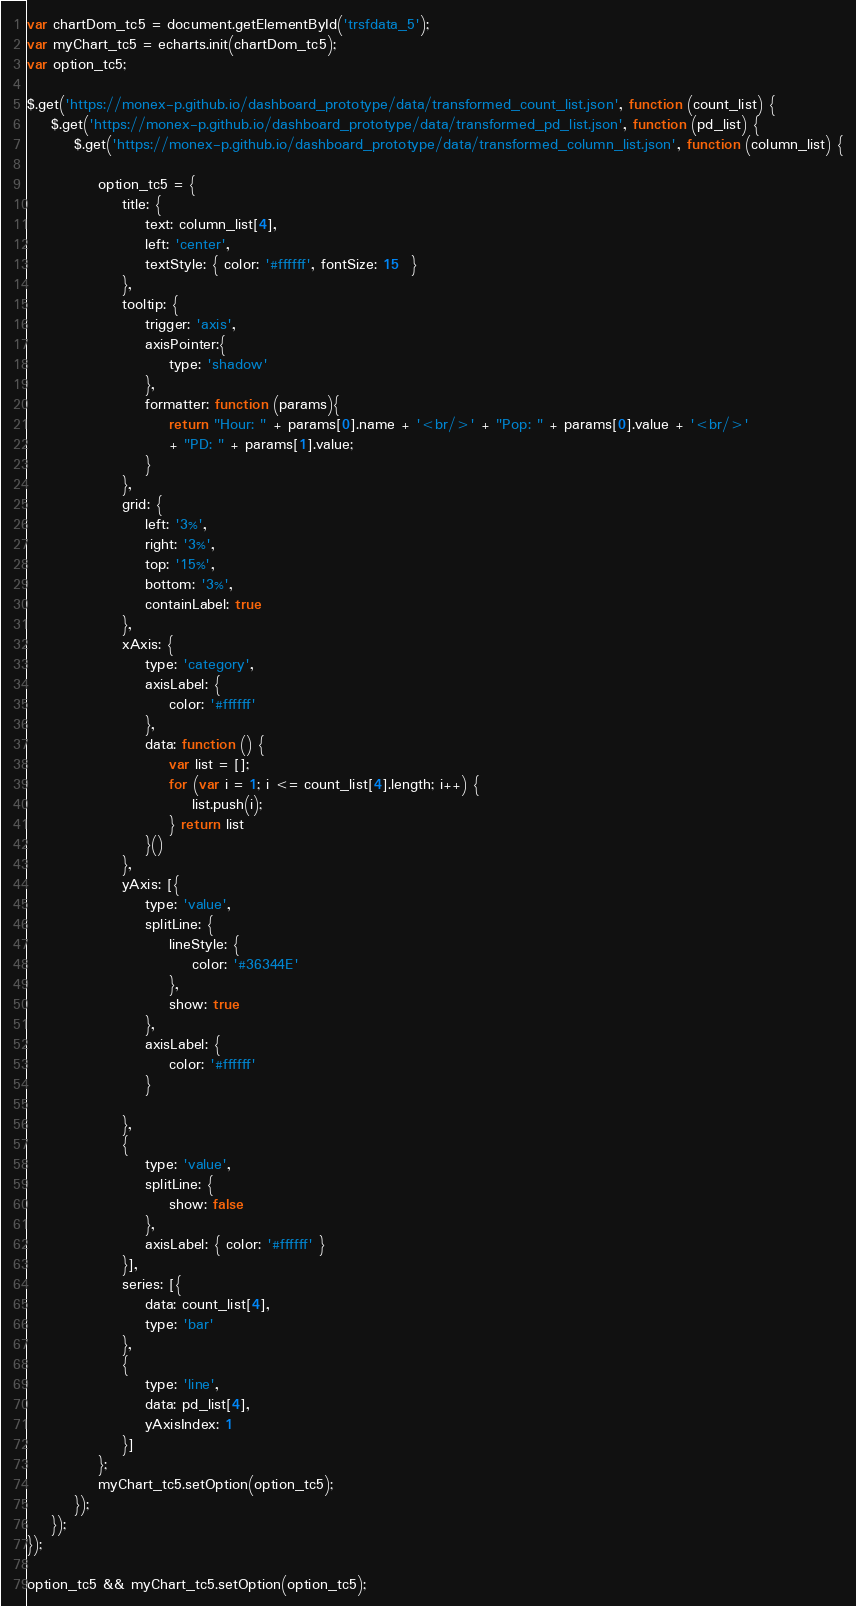<code> <loc_0><loc_0><loc_500><loc_500><_JavaScript_>var chartDom_tc5 = document.getElementById('trsfdata_5');
var myChart_tc5 = echarts.init(chartDom_tc5);
var option_tc5;

$.get('https://monex-p.github.io/dashboard_prototype/data/transformed_count_list.json', function (count_list) {
    $.get('https://monex-p.github.io/dashboard_prototype/data/transformed_pd_list.json', function (pd_list) {
        $.get('https://monex-p.github.io/dashboard_prototype/data/transformed_column_list.json', function (column_list) {

            option_tc5 = {
                title: {
                    text: column_list[4],
                    left: 'center',
                    textStyle: { color: '#ffffff', fontSize: 15  }
                },
                tooltip: {
                    trigger: 'axis',
                    axisPointer:{
                        type: 'shadow'
                    },
                    formatter: function (params){
                        return "Hour: " + params[0].name + '<br/>' + "Pop: " + params[0].value + '<br/>' 
                        + "PD: " + params[1].value;
                    }
                },
                grid: {
                    left: '3%',
                    right: '3%',
                    top: '15%',
                    bottom: '3%',
                    containLabel: true
                },
                xAxis: {
                    type: 'category',
                    axisLabel: {
                        color: '#ffffff'
                    },
                    data: function () {
                        var list = [];
                        for (var i = 1; i <= count_list[4].length; i++) {
                            list.push(i);
                        } return list
                    }()
                },
                yAxis: [{
                    type: 'value',
                    splitLine: {
                        lineStyle: {
                            color: '#36344E'
                        },
                        show: true
                    },
                    axisLabel: {
                        color: '#ffffff'
                    }

                },
                {
                    type: 'value',
                    splitLine: {
                        show: false
                    },
                    axisLabel: { color: '#ffffff' }
                }],
                series: [{
                    data: count_list[4],
                    type: 'bar'
                },
                {
                    type: 'line',
                    data: pd_list[4],
                    yAxisIndex: 1
                }]
            };
            myChart_tc5.setOption(option_tc5);
        });
    });
});

option_tc5 && myChart_tc5.setOption(option_tc5);
</code> 